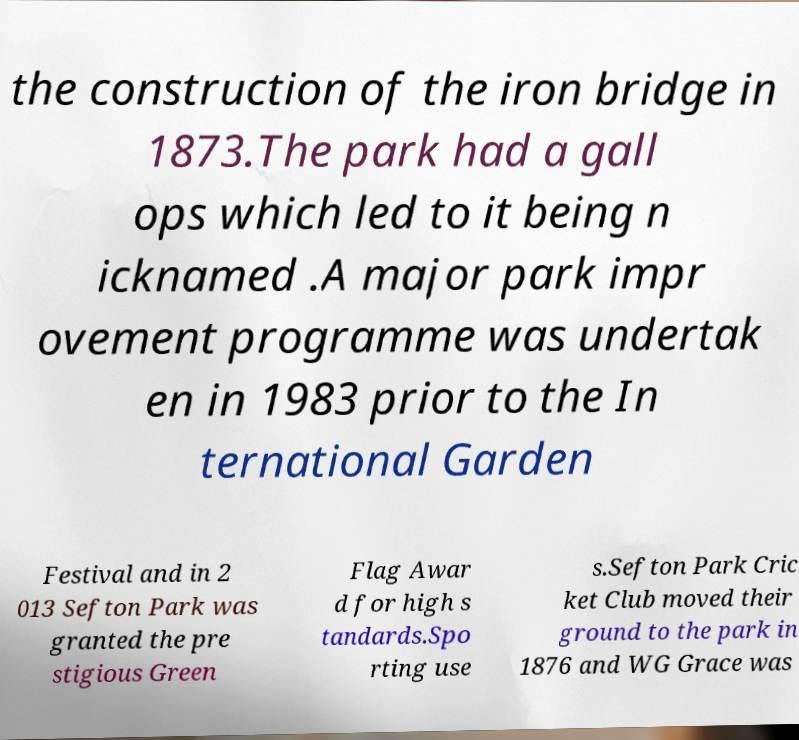For documentation purposes, I need the text within this image transcribed. Could you provide that? the construction of the iron bridge in 1873.The park had a gall ops which led to it being n icknamed .A major park impr ovement programme was undertak en in 1983 prior to the In ternational Garden Festival and in 2 013 Sefton Park was granted the pre stigious Green Flag Awar d for high s tandards.Spo rting use s.Sefton Park Cric ket Club moved their ground to the park in 1876 and WG Grace was 